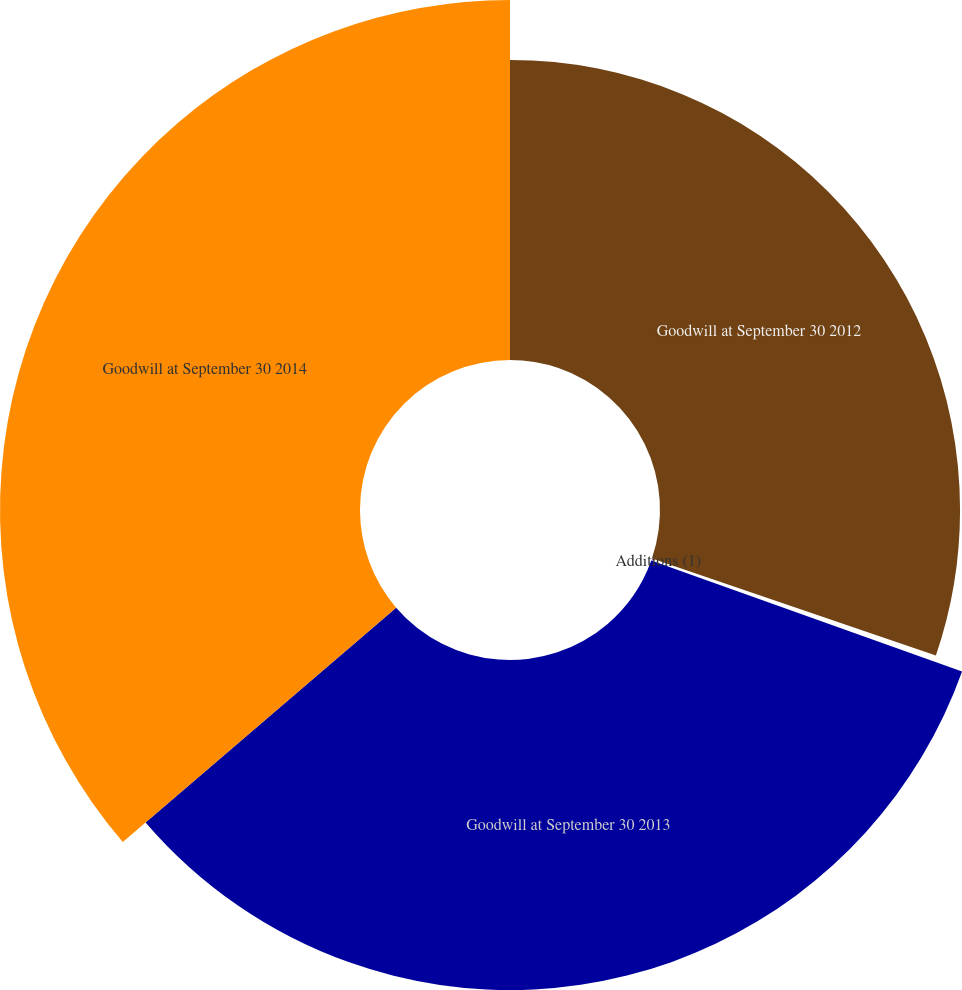Convert chart. <chart><loc_0><loc_0><loc_500><loc_500><pie_chart><fcel>Goodwill at September 30 2012<fcel>Additions (1)<fcel>Goodwill at September 30 2013<fcel>Goodwill at September 30 2014<nl><fcel>30.24%<fcel>0.22%<fcel>33.26%<fcel>36.28%<nl></chart> 